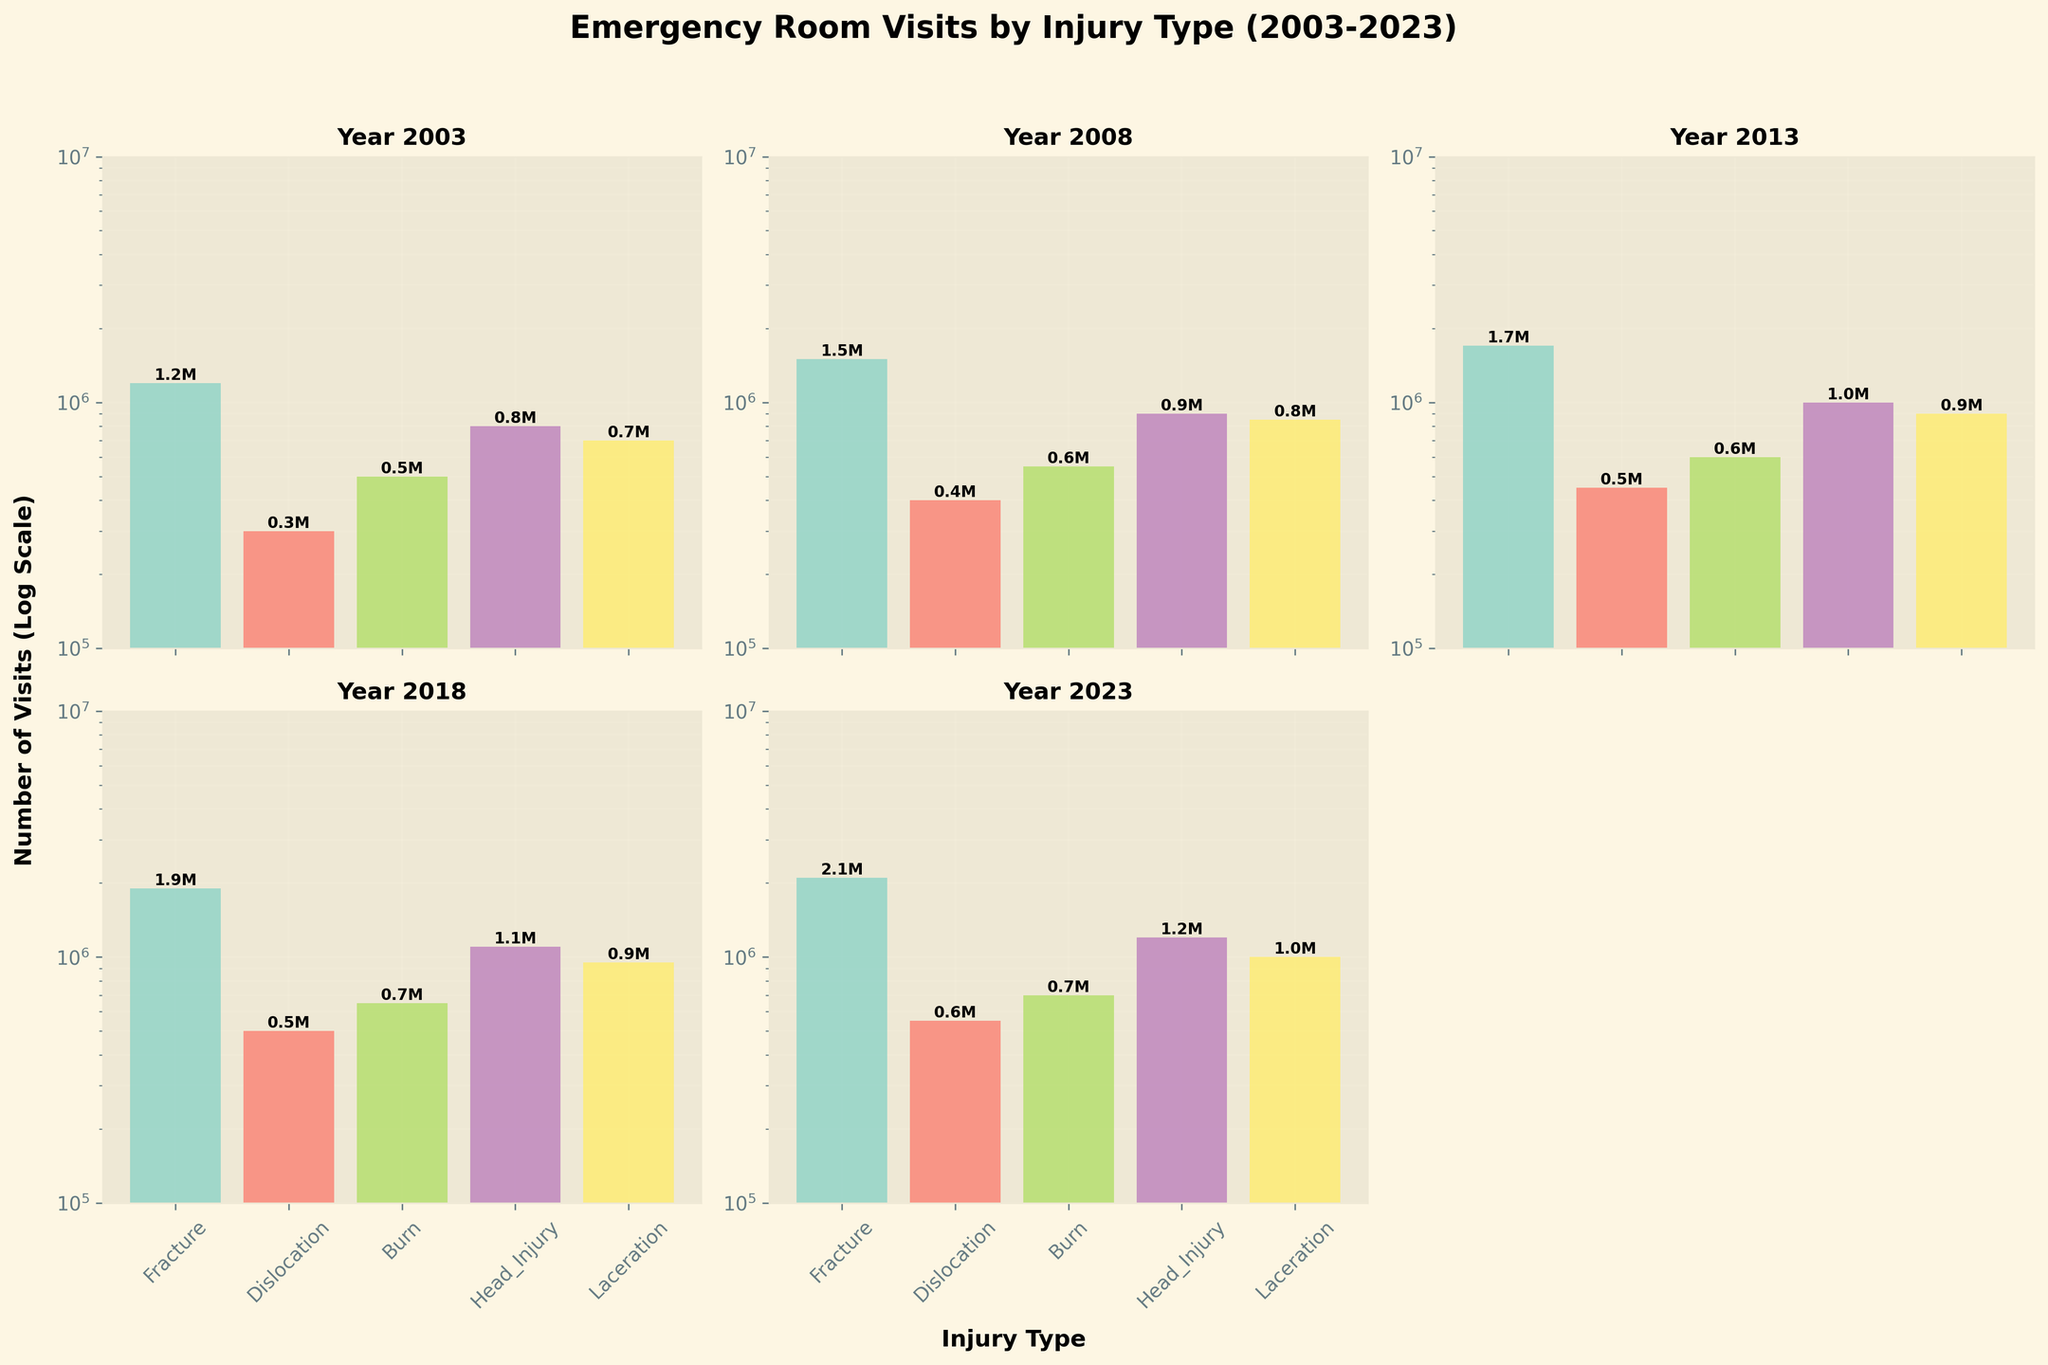What is the title of the figure? The title is usually located at the top center of the figure. It states the main topic of the visualization.
Answer: Emergency Room Visits by Injury Type (2003-2023) Which year has the highest number of visits for 'Fracture' injuries? First, look at the 'Fracture' bars in each subplot and compare their heights. The tallest bar corresponds to the highest number of visits. In this case, the 'Fracture' bar is tallest in the 2023 subplot.
Answer: 2023 What type of injury had the lowest number of visits in 2008? Examine the subplot for the year 2008, identify the bar with the smallest height, and read its label. 'Dislocation' has the lowest bar in 2008.
Answer: Dislocation What is the difference in the number of visits between 'Head Injury' in 2013 and 2023? Identify the 'Head Injury' bar in both 2013 and 2023 subplots. Subtract the number of visits in 2013 (1,000,000) from the number of visits in 2023 (1,200,000).
Answer: 200,000 Which injury type has shown a consistent increase in visits from 2003 to 2023? Track the heights of the bars for each injury type across all subplots from 2003 to 2023. 'Fracture' shows a consistent increase in the number of visits over the years.
Answer: Fracture In which year did 'Burn' injuries see the highest number of visits? Compare the heights of the 'Burn' bars across all subplots. The tallest 'Burn' bar is in the year 2023.
Answer: 2023 What is the average number of visits for 'Laceration' injuries across all years? Read the number of visits for 'Laceration' from each subplot: 700,000 (2003), 850,000 (2008), 900,000 (2013), 950,000 (2018), 1,000,000 (2023). Sum these values and divide by 5: (700,000 + 850,000 + 900,000 + 950,000 + 1,000,000) / 5.
Answer: 880,000 Which year had the most balanced distribution of injury types in terms of visits? Look for a year where the bar heights are the most similar across all injury types. The 2023 subplot shows a relatively balanced distribution, although not perfect, it’s the most balanced compared to others.
Answer: 2023 How many types of injuries had more than 1 million visits in 2023? In the 2023 subplot, count the bars that exceed 1 million visits. 'Fracture' and 'Head Injury' both exceed 1 million visits.
Answer: 2 